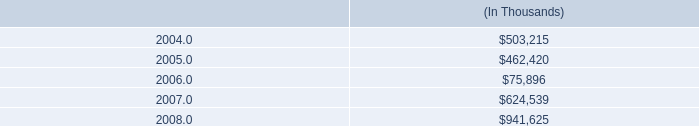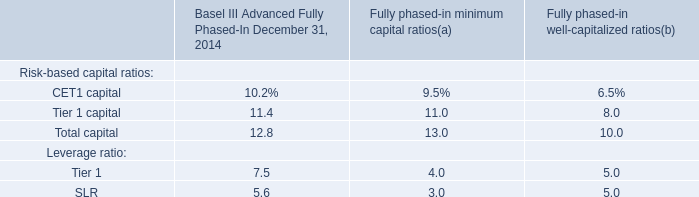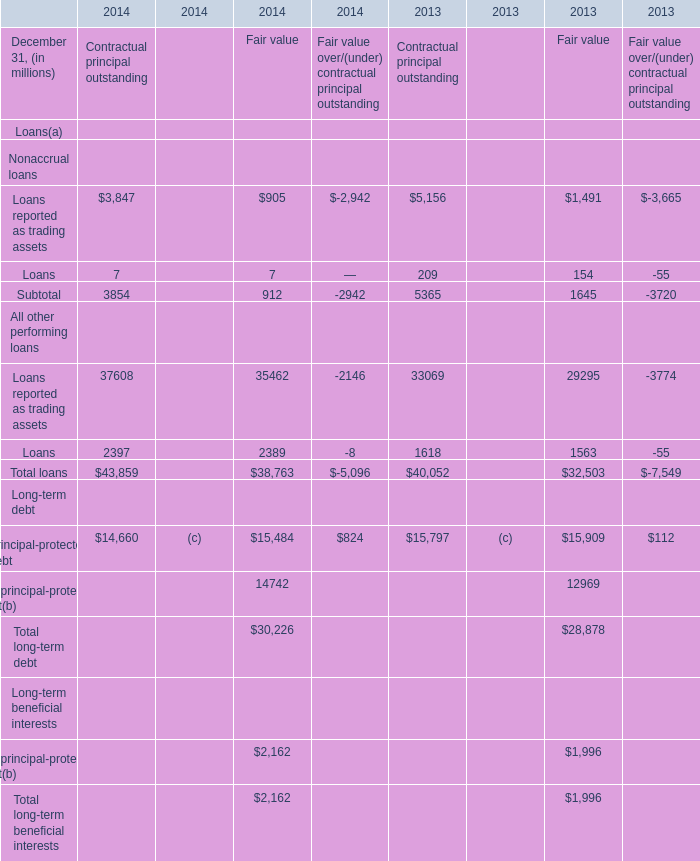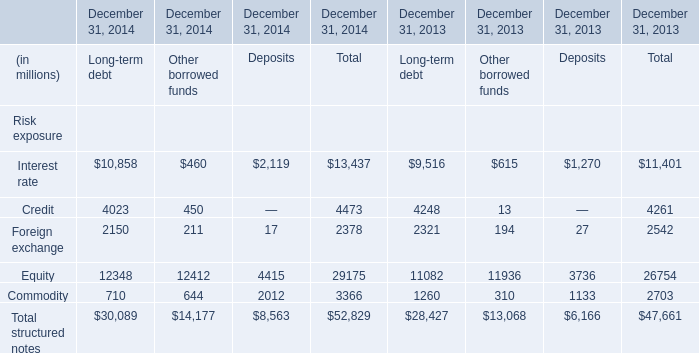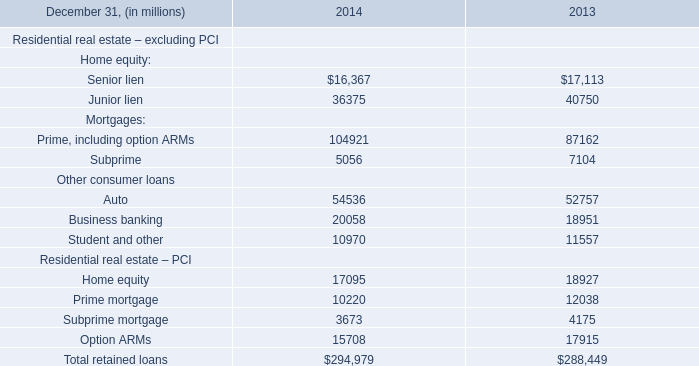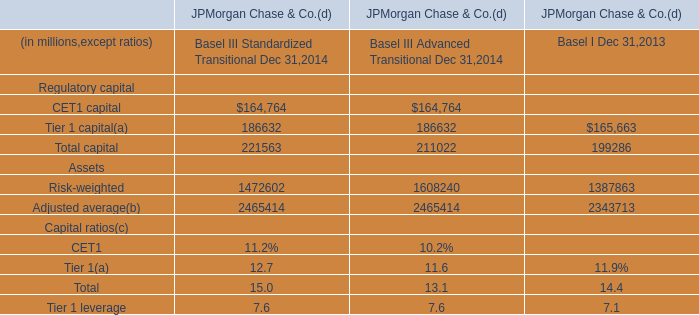What is the ratio of all Deposits that are smaller than 3000 to the sum of Deposits, in 2014? 
Computations: (((2119 + 2012) + 17) / 8563)
Answer: 0.48441. 